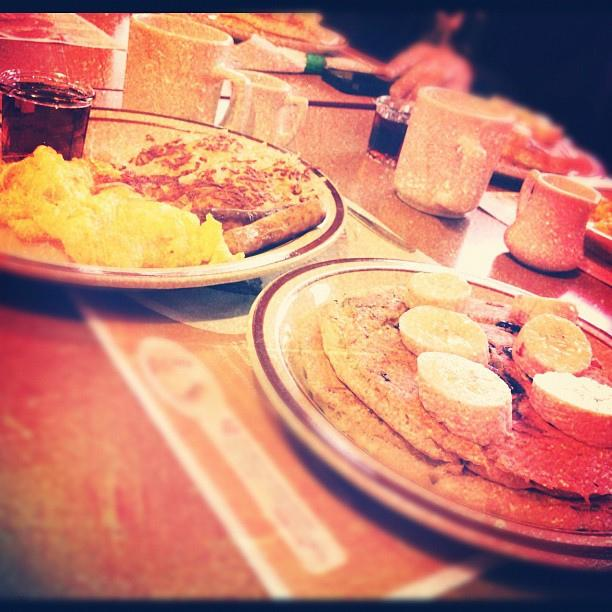What color are the fruits sliced out on top of the pancake? Please explain your reasoning. white. The fruits are white. 